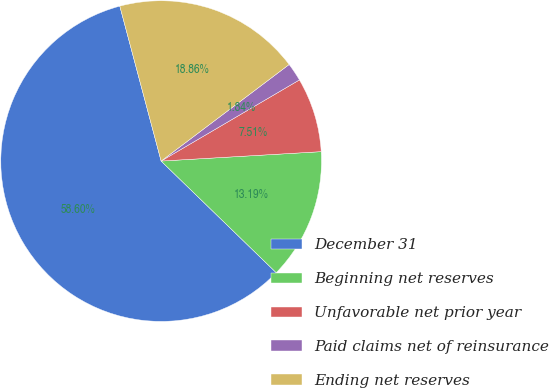<chart> <loc_0><loc_0><loc_500><loc_500><pie_chart><fcel>December 31<fcel>Beginning net reserves<fcel>Unfavorable net prior year<fcel>Paid claims net of reinsurance<fcel>Ending net reserves<nl><fcel>58.59%<fcel>13.19%<fcel>7.51%<fcel>1.84%<fcel>18.86%<nl></chart> 